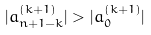<formula> <loc_0><loc_0><loc_500><loc_500>| a _ { n + 1 - k } ^ { ( k + 1 ) } | > | a _ { 0 } ^ { ( k + 1 ) } |</formula> 